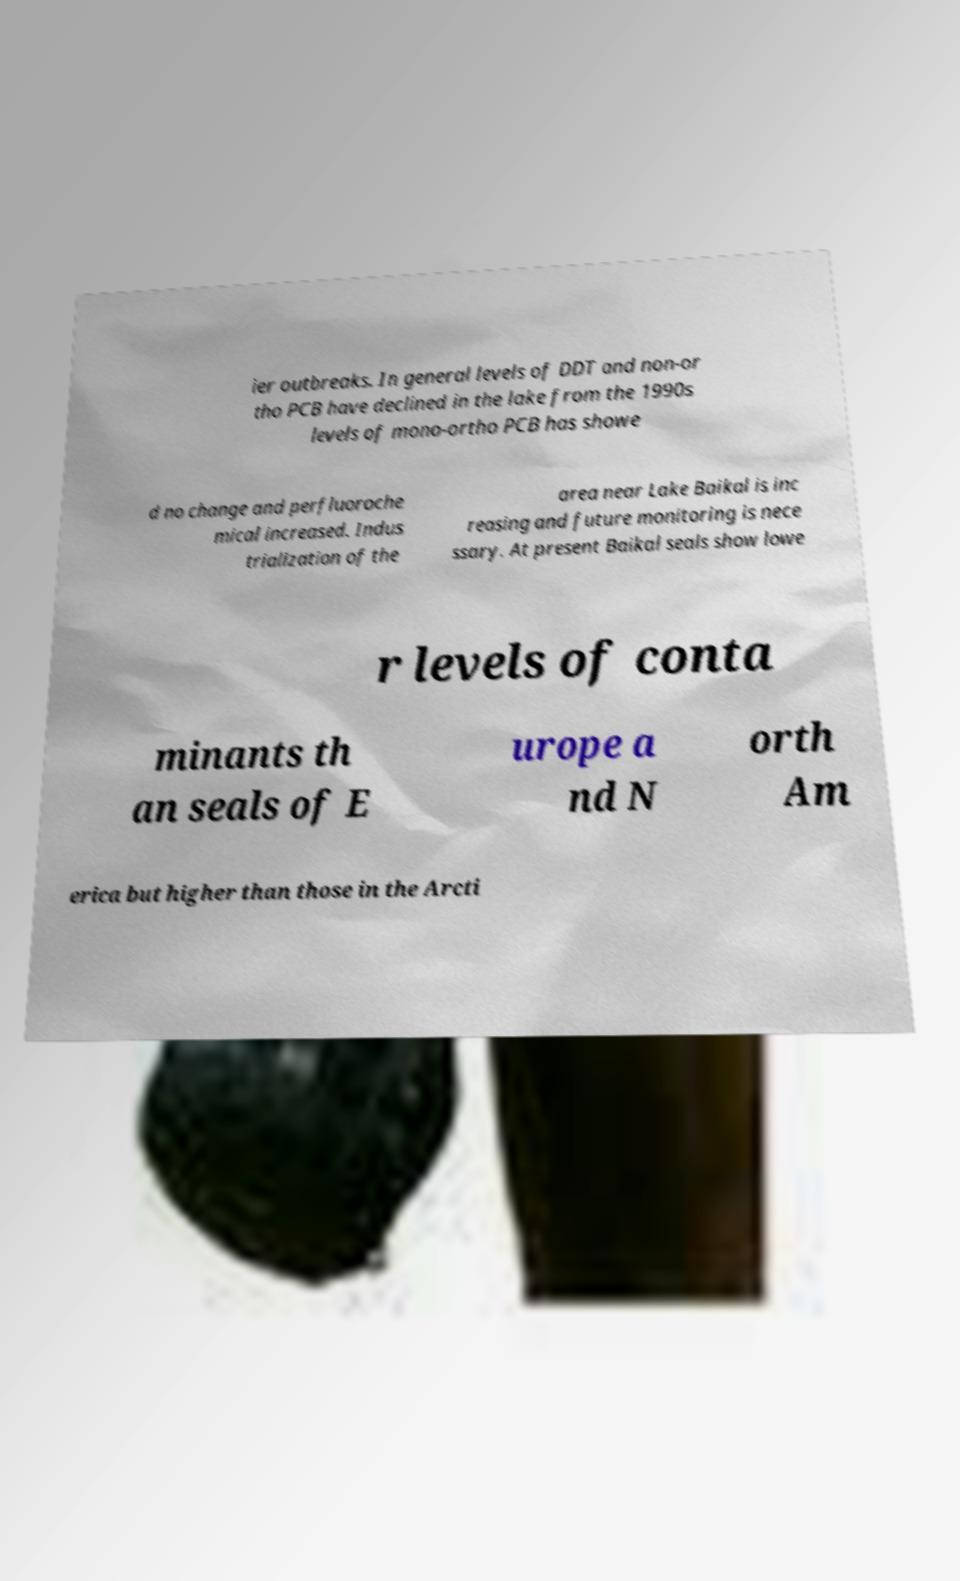Please identify and transcribe the text found in this image. ier outbreaks. In general levels of DDT and non-or tho PCB have declined in the lake from the 1990s levels of mono-ortho PCB has showe d no change and perfluoroche mical increased. Indus trialization of the area near Lake Baikal is inc reasing and future monitoring is nece ssary. At present Baikal seals show lowe r levels of conta minants th an seals of E urope a nd N orth Am erica but higher than those in the Arcti 